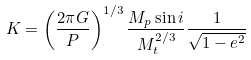<formula> <loc_0><loc_0><loc_500><loc_500>K = \left ( \frac { 2 \pi G } { P } \right ) ^ { 1 / 3 } \frac { M _ { p } \sin i } { M _ { t } ^ { 2 / 3 } } \frac { 1 } { \sqrt { 1 - e ^ { 2 } } }</formula> 